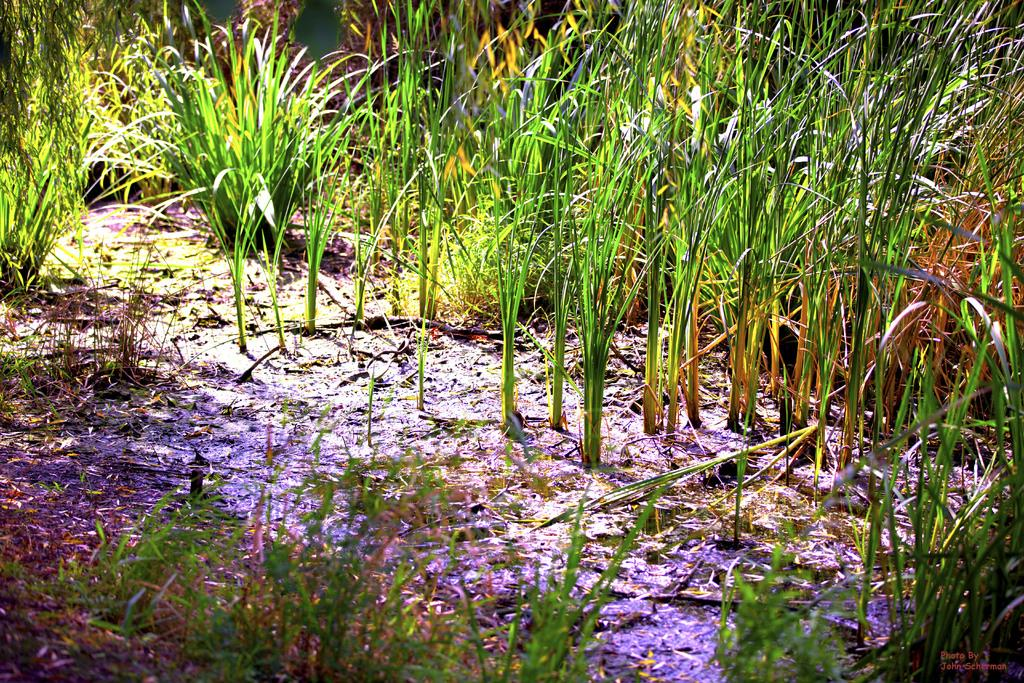What objects on the ground resemble planets in the image? There are objects on the ground that resemble planets in the image. What type of bridge can be seen connecting the planets in the image? There is no bridge connecting the planets in the image, as the objects resembling planets are on the ground. 